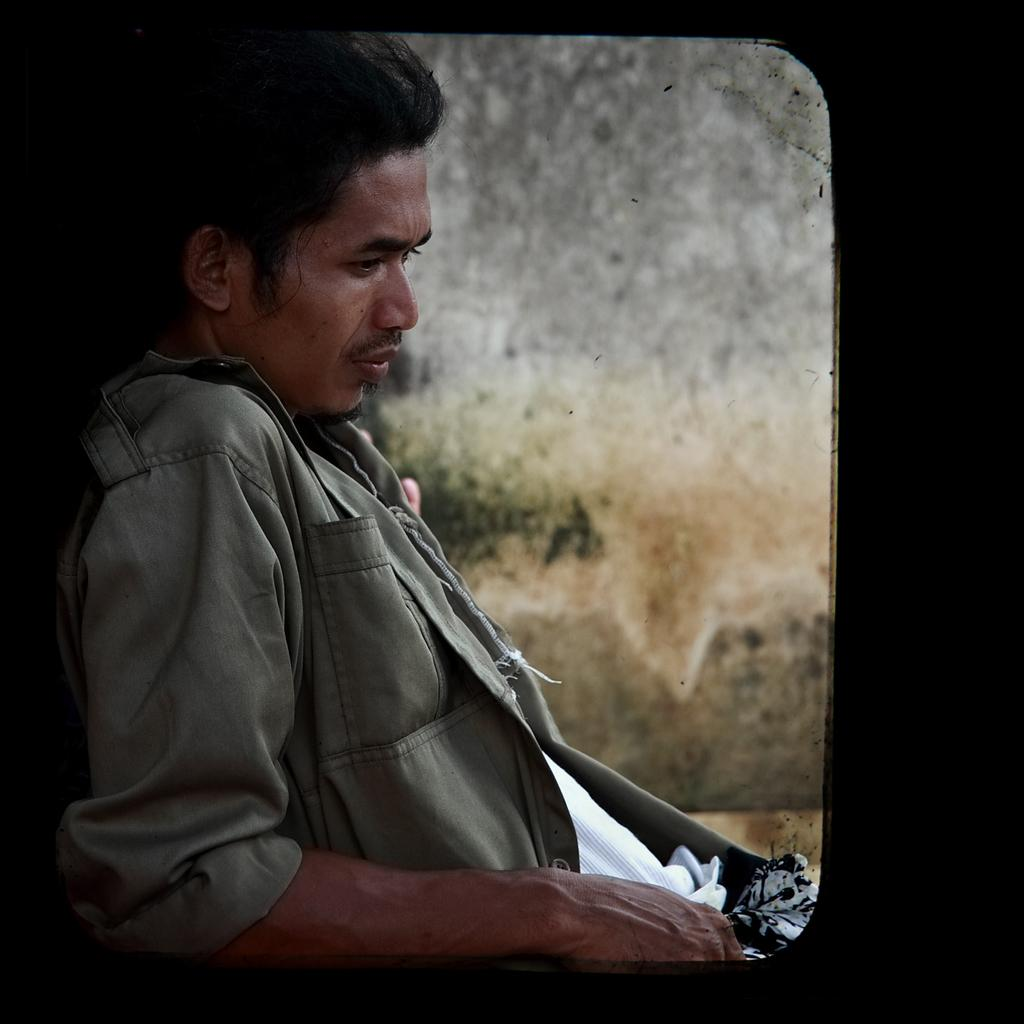What is the main subject of the image? There is a person in the image. What is the person doing in the image? The person is sitting in a vehicle. What type of sock is the scarecrow wearing in the image? There is no scarecrow or sock present in the image. 